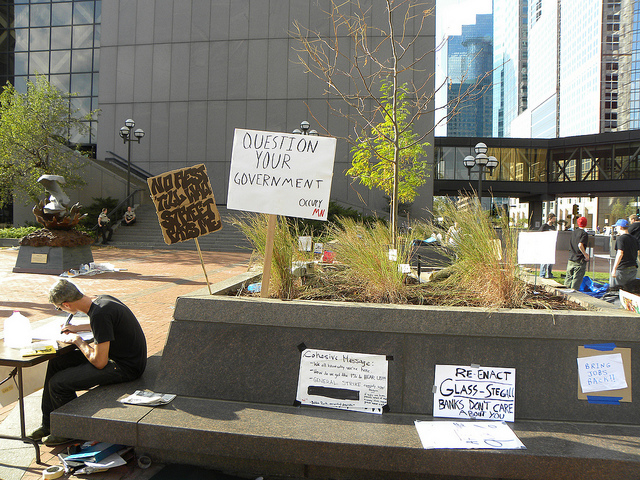What is the man participating in?
A. protest
B. play
C. concert
D. sale
Answer with the option's letter from the given choices directly. A 